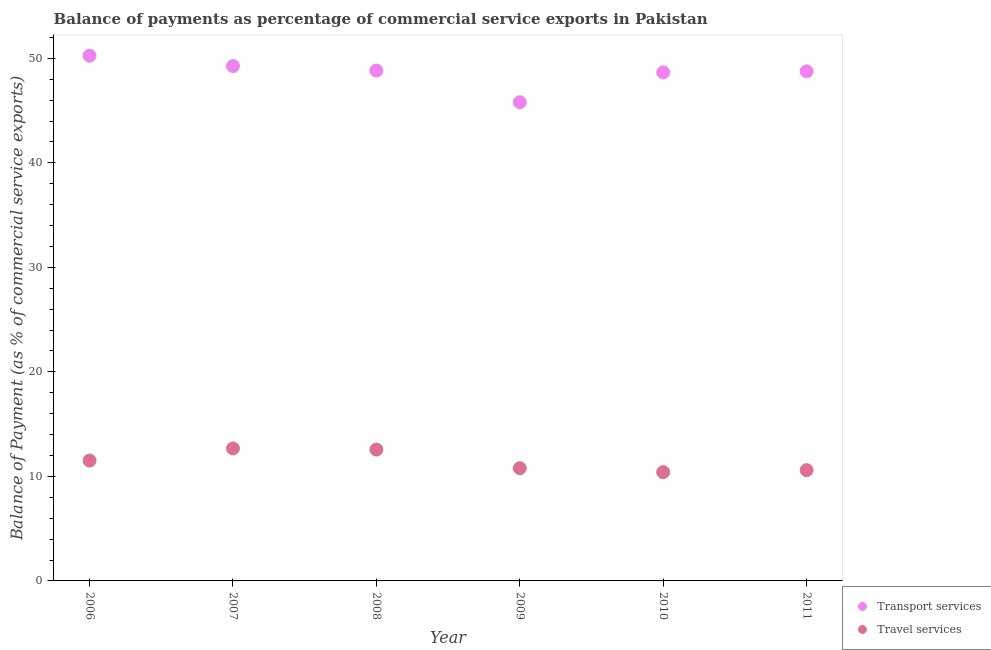How many different coloured dotlines are there?
Make the answer very short. 2. What is the balance of payments of transport services in 2007?
Provide a short and direct response. 49.26. Across all years, what is the maximum balance of payments of travel services?
Give a very brief answer. 12.67. Across all years, what is the minimum balance of payments of travel services?
Ensure brevity in your answer.  10.41. In which year was the balance of payments of transport services maximum?
Offer a terse response. 2006. What is the total balance of payments of travel services in the graph?
Provide a succinct answer. 68.54. What is the difference between the balance of payments of travel services in 2007 and that in 2009?
Your response must be concise. 1.89. What is the difference between the balance of payments of travel services in 2006 and the balance of payments of transport services in 2008?
Give a very brief answer. -37.31. What is the average balance of payments of travel services per year?
Provide a succinct answer. 11.42. In the year 2011, what is the difference between the balance of payments of transport services and balance of payments of travel services?
Your answer should be very brief. 38.15. What is the ratio of the balance of payments of transport services in 2006 to that in 2009?
Ensure brevity in your answer.  1.1. Is the balance of payments of travel services in 2009 less than that in 2010?
Ensure brevity in your answer.  No. What is the difference between the highest and the second highest balance of payments of transport services?
Ensure brevity in your answer.  0.99. What is the difference between the highest and the lowest balance of payments of transport services?
Offer a very short reply. 4.45. In how many years, is the balance of payments of transport services greater than the average balance of payments of transport services taken over all years?
Provide a succinct answer. 5. Is the balance of payments of transport services strictly less than the balance of payments of travel services over the years?
Make the answer very short. No. How many dotlines are there?
Provide a succinct answer. 2. How many years are there in the graph?
Offer a terse response. 6. What is the difference between two consecutive major ticks on the Y-axis?
Offer a terse response. 10. Are the values on the major ticks of Y-axis written in scientific E-notation?
Give a very brief answer. No. Does the graph contain grids?
Offer a terse response. No. Where does the legend appear in the graph?
Give a very brief answer. Bottom right. What is the title of the graph?
Your response must be concise. Balance of payments as percentage of commercial service exports in Pakistan. Does "Male population" appear as one of the legend labels in the graph?
Provide a short and direct response. No. What is the label or title of the X-axis?
Offer a very short reply. Year. What is the label or title of the Y-axis?
Your answer should be compact. Balance of Payment (as % of commercial service exports). What is the Balance of Payment (as % of commercial service exports) of Transport services in 2006?
Your response must be concise. 50.25. What is the Balance of Payment (as % of commercial service exports) in Travel services in 2006?
Make the answer very short. 11.51. What is the Balance of Payment (as % of commercial service exports) of Transport services in 2007?
Your answer should be very brief. 49.26. What is the Balance of Payment (as % of commercial service exports) in Travel services in 2007?
Make the answer very short. 12.67. What is the Balance of Payment (as % of commercial service exports) of Transport services in 2008?
Keep it short and to the point. 48.83. What is the Balance of Payment (as % of commercial service exports) of Travel services in 2008?
Keep it short and to the point. 12.56. What is the Balance of Payment (as % of commercial service exports) in Transport services in 2009?
Offer a terse response. 45.8. What is the Balance of Payment (as % of commercial service exports) in Travel services in 2009?
Provide a succinct answer. 10.79. What is the Balance of Payment (as % of commercial service exports) in Transport services in 2010?
Provide a short and direct response. 48.65. What is the Balance of Payment (as % of commercial service exports) in Travel services in 2010?
Keep it short and to the point. 10.41. What is the Balance of Payment (as % of commercial service exports) of Transport services in 2011?
Your answer should be compact. 48.75. What is the Balance of Payment (as % of commercial service exports) in Travel services in 2011?
Provide a succinct answer. 10.6. Across all years, what is the maximum Balance of Payment (as % of commercial service exports) in Transport services?
Your answer should be compact. 50.25. Across all years, what is the maximum Balance of Payment (as % of commercial service exports) of Travel services?
Your answer should be compact. 12.67. Across all years, what is the minimum Balance of Payment (as % of commercial service exports) of Transport services?
Offer a terse response. 45.8. Across all years, what is the minimum Balance of Payment (as % of commercial service exports) of Travel services?
Your answer should be very brief. 10.41. What is the total Balance of Payment (as % of commercial service exports) of Transport services in the graph?
Your response must be concise. 291.54. What is the total Balance of Payment (as % of commercial service exports) in Travel services in the graph?
Offer a terse response. 68.54. What is the difference between the Balance of Payment (as % of commercial service exports) of Travel services in 2006 and that in 2007?
Offer a terse response. -1.16. What is the difference between the Balance of Payment (as % of commercial service exports) in Transport services in 2006 and that in 2008?
Provide a short and direct response. 1.42. What is the difference between the Balance of Payment (as % of commercial service exports) of Travel services in 2006 and that in 2008?
Make the answer very short. -1.05. What is the difference between the Balance of Payment (as % of commercial service exports) in Transport services in 2006 and that in 2009?
Provide a short and direct response. 4.45. What is the difference between the Balance of Payment (as % of commercial service exports) of Travel services in 2006 and that in 2009?
Ensure brevity in your answer.  0.73. What is the difference between the Balance of Payment (as % of commercial service exports) in Transport services in 2006 and that in 2010?
Your answer should be compact. 1.6. What is the difference between the Balance of Payment (as % of commercial service exports) in Travel services in 2006 and that in 2010?
Offer a very short reply. 1.11. What is the difference between the Balance of Payment (as % of commercial service exports) of Transport services in 2006 and that in 2011?
Provide a short and direct response. 1.49. What is the difference between the Balance of Payment (as % of commercial service exports) of Travel services in 2006 and that in 2011?
Ensure brevity in your answer.  0.91. What is the difference between the Balance of Payment (as % of commercial service exports) of Transport services in 2007 and that in 2008?
Give a very brief answer. 0.43. What is the difference between the Balance of Payment (as % of commercial service exports) of Travel services in 2007 and that in 2008?
Your response must be concise. 0.11. What is the difference between the Balance of Payment (as % of commercial service exports) in Transport services in 2007 and that in 2009?
Your response must be concise. 3.46. What is the difference between the Balance of Payment (as % of commercial service exports) in Travel services in 2007 and that in 2009?
Keep it short and to the point. 1.89. What is the difference between the Balance of Payment (as % of commercial service exports) in Transport services in 2007 and that in 2010?
Offer a terse response. 0.61. What is the difference between the Balance of Payment (as % of commercial service exports) in Travel services in 2007 and that in 2010?
Your answer should be compact. 2.27. What is the difference between the Balance of Payment (as % of commercial service exports) of Transport services in 2007 and that in 2011?
Provide a short and direct response. 0.5. What is the difference between the Balance of Payment (as % of commercial service exports) of Travel services in 2007 and that in 2011?
Give a very brief answer. 2.08. What is the difference between the Balance of Payment (as % of commercial service exports) of Transport services in 2008 and that in 2009?
Give a very brief answer. 3.03. What is the difference between the Balance of Payment (as % of commercial service exports) of Travel services in 2008 and that in 2009?
Your answer should be compact. 1.78. What is the difference between the Balance of Payment (as % of commercial service exports) of Transport services in 2008 and that in 2010?
Make the answer very short. 0.17. What is the difference between the Balance of Payment (as % of commercial service exports) of Travel services in 2008 and that in 2010?
Provide a succinct answer. 2.16. What is the difference between the Balance of Payment (as % of commercial service exports) of Transport services in 2008 and that in 2011?
Your response must be concise. 0.07. What is the difference between the Balance of Payment (as % of commercial service exports) in Travel services in 2008 and that in 2011?
Your answer should be compact. 1.97. What is the difference between the Balance of Payment (as % of commercial service exports) in Transport services in 2009 and that in 2010?
Offer a terse response. -2.86. What is the difference between the Balance of Payment (as % of commercial service exports) in Travel services in 2009 and that in 2010?
Offer a terse response. 0.38. What is the difference between the Balance of Payment (as % of commercial service exports) in Transport services in 2009 and that in 2011?
Your answer should be compact. -2.96. What is the difference between the Balance of Payment (as % of commercial service exports) in Travel services in 2009 and that in 2011?
Your answer should be compact. 0.19. What is the difference between the Balance of Payment (as % of commercial service exports) of Transport services in 2010 and that in 2011?
Make the answer very short. -0.1. What is the difference between the Balance of Payment (as % of commercial service exports) in Travel services in 2010 and that in 2011?
Your answer should be compact. -0.19. What is the difference between the Balance of Payment (as % of commercial service exports) in Transport services in 2006 and the Balance of Payment (as % of commercial service exports) in Travel services in 2007?
Ensure brevity in your answer.  37.57. What is the difference between the Balance of Payment (as % of commercial service exports) in Transport services in 2006 and the Balance of Payment (as % of commercial service exports) in Travel services in 2008?
Keep it short and to the point. 37.68. What is the difference between the Balance of Payment (as % of commercial service exports) of Transport services in 2006 and the Balance of Payment (as % of commercial service exports) of Travel services in 2009?
Make the answer very short. 39.46. What is the difference between the Balance of Payment (as % of commercial service exports) of Transport services in 2006 and the Balance of Payment (as % of commercial service exports) of Travel services in 2010?
Offer a terse response. 39.84. What is the difference between the Balance of Payment (as % of commercial service exports) in Transport services in 2006 and the Balance of Payment (as % of commercial service exports) in Travel services in 2011?
Keep it short and to the point. 39.65. What is the difference between the Balance of Payment (as % of commercial service exports) of Transport services in 2007 and the Balance of Payment (as % of commercial service exports) of Travel services in 2008?
Provide a succinct answer. 36.69. What is the difference between the Balance of Payment (as % of commercial service exports) in Transport services in 2007 and the Balance of Payment (as % of commercial service exports) in Travel services in 2009?
Provide a succinct answer. 38.47. What is the difference between the Balance of Payment (as % of commercial service exports) of Transport services in 2007 and the Balance of Payment (as % of commercial service exports) of Travel services in 2010?
Your answer should be compact. 38.85. What is the difference between the Balance of Payment (as % of commercial service exports) in Transport services in 2007 and the Balance of Payment (as % of commercial service exports) in Travel services in 2011?
Your answer should be very brief. 38.66. What is the difference between the Balance of Payment (as % of commercial service exports) of Transport services in 2008 and the Balance of Payment (as % of commercial service exports) of Travel services in 2009?
Your answer should be very brief. 38.04. What is the difference between the Balance of Payment (as % of commercial service exports) of Transport services in 2008 and the Balance of Payment (as % of commercial service exports) of Travel services in 2010?
Give a very brief answer. 38.42. What is the difference between the Balance of Payment (as % of commercial service exports) in Transport services in 2008 and the Balance of Payment (as % of commercial service exports) in Travel services in 2011?
Your answer should be compact. 38.23. What is the difference between the Balance of Payment (as % of commercial service exports) in Transport services in 2009 and the Balance of Payment (as % of commercial service exports) in Travel services in 2010?
Your answer should be very brief. 35.39. What is the difference between the Balance of Payment (as % of commercial service exports) of Transport services in 2009 and the Balance of Payment (as % of commercial service exports) of Travel services in 2011?
Give a very brief answer. 35.2. What is the difference between the Balance of Payment (as % of commercial service exports) in Transport services in 2010 and the Balance of Payment (as % of commercial service exports) in Travel services in 2011?
Offer a very short reply. 38.05. What is the average Balance of Payment (as % of commercial service exports) of Transport services per year?
Ensure brevity in your answer.  48.59. What is the average Balance of Payment (as % of commercial service exports) in Travel services per year?
Your answer should be compact. 11.42. In the year 2006, what is the difference between the Balance of Payment (as % of commercial service exports) in Transport services and Balance of Payment (as % of commercial service exports) in Travel services?
Make the answer very short. 38.74. In the year 2007, what is the difference between the Balance of Payment (as % of commercial service exports) in Transport services and Balance of Payment (as % of commercial service exports) in Travel services?
Offer a very short reply. 36.58. In the year 2008, what is the difference between the Balance of Payment (as % of commercial service exports) in Transport services and Balance of Payment (as % of commercial service exports) in Travel services?
Your response must be concise. 36.26. In the year 2009, what is the difference between the Balance of Payment (as % of commercial service exports) of Transport services and Balance of Payment (as % of commercial service exports) of Travel services?
Provide a succinct answer. 35.01. In the year 2010, what is the difference between the Balance of Payment (as % of commercial service exports) of Transport services and Balance of Payment (as % of commercial service exports) of Travel services?
Give a very brief answer. 38.25. In the year 2011, what is the difference between the Balance of Payment (as % of commercial service exports) of Transport services and Balance of Payment (as % of commercial service exports) of Travel services?
Your answer should be very brief. 38.15. What is the ratio of the Balance of Payment (as % of commercial service exports) of Transport services in 2006 to that in 2007?
Keep it short and to the point. 1.02. What is the ratio of the Balance of Payment (as % of commercial service exports) of Travel services in 2006 to that in 2007?
Provide a short and direct response. 0.91. What is the ratio of the Balance of Payment (as % of commercial service exports) of Transport services in 2006 to that in 2008?
Your response must be concise. 1.03. What is the ratio of the Balance of Payment (as % of commercial service exports) of Travel services in 2006 to that in 2008?
Your response must be concise. 0.92. What is the ratio of the Balance of Payment (as % of commercial service exports) in Transport services in 2006 to that in 2009?
Offer a very short reply. 1.1. What is the ratio of the Balance of Payment (as % of commercial service exports) in Travel services in 2006 to that in 2009?
Ensure brevity in your answer.  1.07. What is the ratio of the Balance of Payment (as % of commercial service exports) in Transport services in 2006 to that in 2010?
Offer a terse response. 1.03. What is the ratio of the Balance of Payment (as % of commercial service exports) in Travel services in 2006 to that in 2010?
Provide a succinct answer. 1.11. What is the ratio of the Balance of Payment (as % of commercial service exports) in Transport services in 2006 to that in 2011?
Offer a very short reply. 1.03. What is the ratio of the Balance of Payment (as % of commercial service exports) in Travel services in 2006 to that in 2011?
Your answer should be very brief. 1.09. What is the ratio of the Balance of Payment (as % of commercial service exports) of Transport services in 2007 to that in 2008?
Offer a terse response. 1.01. What is the ratio of the Balance of Payment (as % of commercial service exports) of Travel services in 2007 to that in 2008?
Keep it short and to the point. 1.01. What is the ratio of the Balance of Payment (as % of commercial service exports) in Transport services in 2007 to that in 2009?
Ensure brevity in your answer.  1.08. What is the ratio of the Balance of Payment (as % of commercial service exports) of Travel services in 2007 to that in 2009?
Offer a terse response. 1.18. What is the ratio of the Balance of Payment (as % of commercial service exports) of Transport services in 2007 to that in 2010?
Make the answer very short. 1.01. What is the ratio of the Balance of Payment (as % of commercial service exports) of Travel services in 2007 to that in 2010?
Provide a succinct answer. 1.22. What is the ratio of the Balance of Payment (as % of commercial service exports) in Transport services in 2007 to that in 2011?
Keep it short and to the point. 1.01. What is the ratio of the Balance of Payment (as % of commercial service exports) in Travel services in 2007 to that in 2011?
Your answer should be very brief. 1.2. What is the ratio of the Balance of Payment (as % of commercial service exports) in Transport services in 2008 to that in 2009?
Ensure brevity in your answer.  1.07. What is the ratio of the Balance of Payment (as % of commercial service exports) in Travel services in 2008 to that in 2009?
Offer a terse response. 1.17. What is the ratio of the Balance of Payment (as % of commercial service exports) in Travel services in 2008 to that in 2010?
Your response must be concise. 1.21. What is the ratio of the Balance of Payment (as % of commercial service exports) in Travel services in 2008 to that in 2011?
Keep it short and to the point. 1.19. What is the ratio of the Balance of Payment (as % of commercial service exports) in Transport services in 2009 to that in 2010?
Your answer should be compact. 0.94. What is the ratio of the Balance of Payment (as % of commercial service exports) in Travel services in 2009 to that in 2010?
Offer a very short reply. 1.04. What is the ratio of the Balance of Payment (as % of commercial service exports) in Transport services in 2009 to that in 2011?
Your response must be concise. 0.94. What is the ratio of the Balance of Payment (as % of commercial service exports) in Travel services in 2009 to that in 2011?
Your answer should be very brief. 1.02. What is the ratio of the Balance of Payment (as % of commercial service exports) in Travel services in 2010 to that in 2011?
Provide a succinct answer. 0.98. What is the difference between the highest and the second highest Balance of Payment (as % of commercial service exports) in Transport services?
Your answer should be compact. 0.99. What is the difference between the highest and the second highest Balance of Payment (as % of commercial service exports) of Travel services?
Offer a terse response. 0.11. What is the difference between the highest and the lowest Balance of Payment (as % of commercial service exports) of Transport services?
Provide a short and direct response. 4.45. What is the difference between the highest and the lowest Balance of Payment (as % of commercial service exports) of Travel services?
Ensure brevity in your answer.  2.27. 